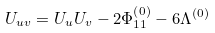Convert formula to latex. <formula><loc_0><loc_0><loc_500><loc_500>U _ { u v } = U _ { u } U _ { v } - 2 \Phi _ { 1 1 } ^ { \left ( 0 \right ) } - 6 \Lambda ^ { \left ( 0 \right ) }</formula> 